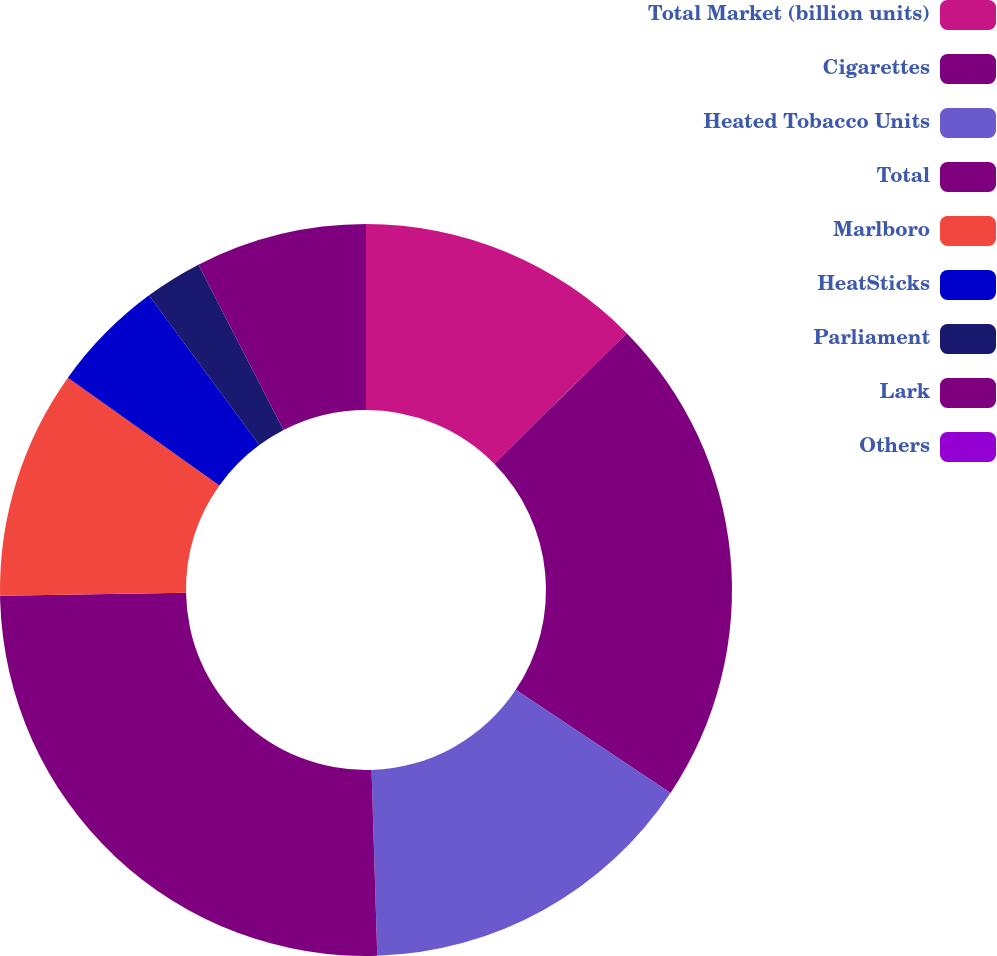Convert chart. <chart><loc_0><loc_0><loc_500><loc_500><pie_chart><fcel>Total Market (billion units)<fcel>Cigarettes<fcel>Heated Tobacco Units<fcel>Total<fcel>Marlboro<fcel>HeatSticks<fcel>Parliament<fcel>Lark<fcel>Others<nl><fcel>12.62%<fcel>21.74%<fcel>15.15%<fcel>25.24%<fcel>10.1%<fcel>5.05%<fcel>2.53%<fcel>7.57%<fcel>0.0%<nl></chart> 